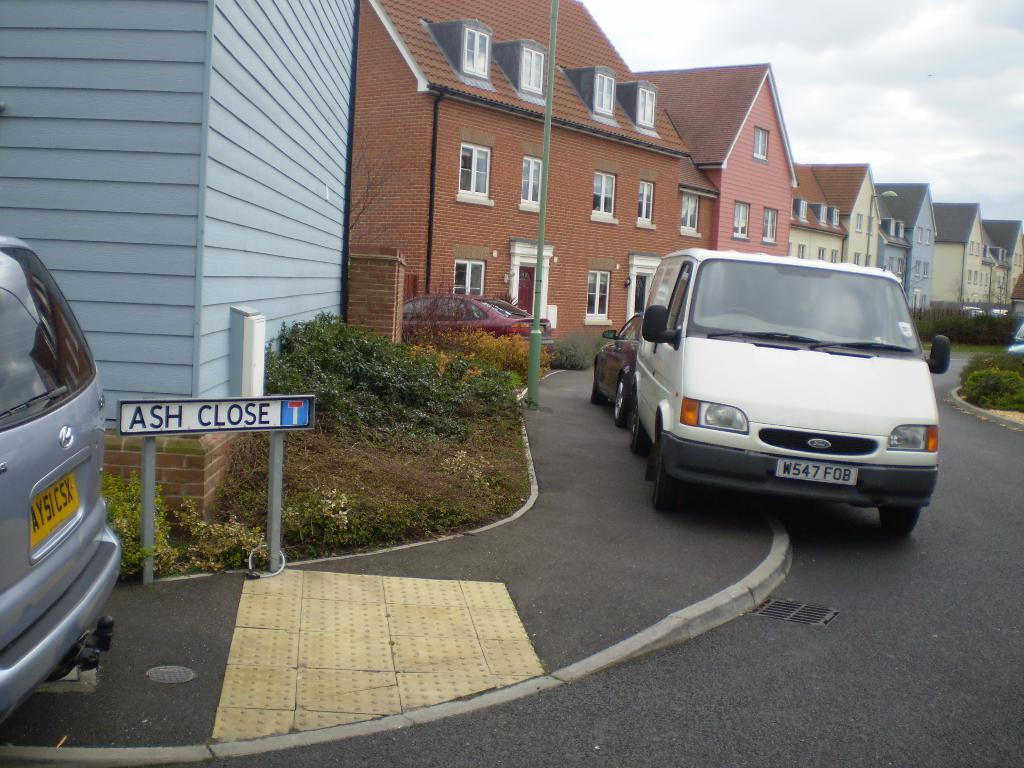What can be seen on the road in the image? There are cars on the road in the image. What is visible in the background of the image? There are buildings, trees, and the sky visible in the background of the image. What object is present in the image that might be used for displaying information? There is a board present in the image. Where is the table located in the image? There is no table present in the image. What type of shock can be seen affecting the buildings in the image? There is no shock or any indication of an event affecting the buildings in the image. 